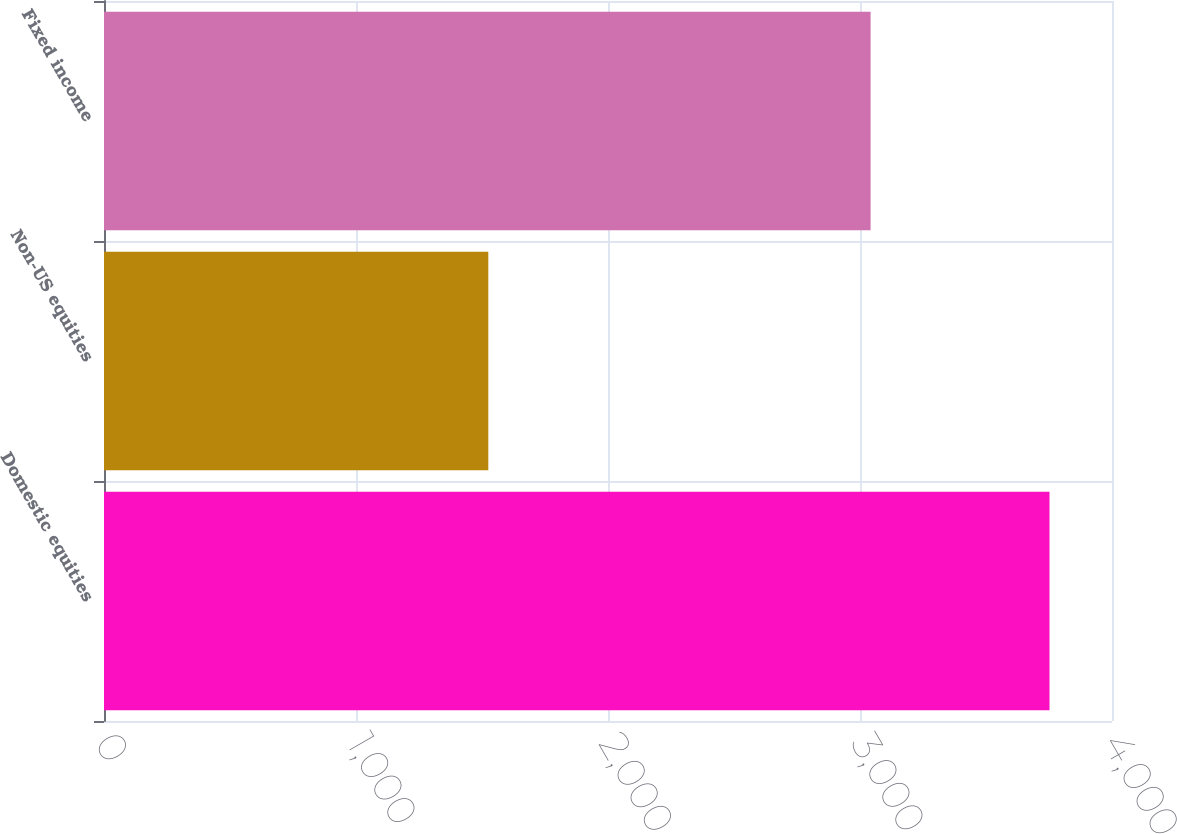Convert chart. <chart><loc_0><loc_0><loc_500><loc_500><bar_chart><fcel>Domestic equities<fcel>Non-US equities<fcel>Fixed income<nl><fcel>3752<fcel>1525<fcel>3042<nl></chart> 